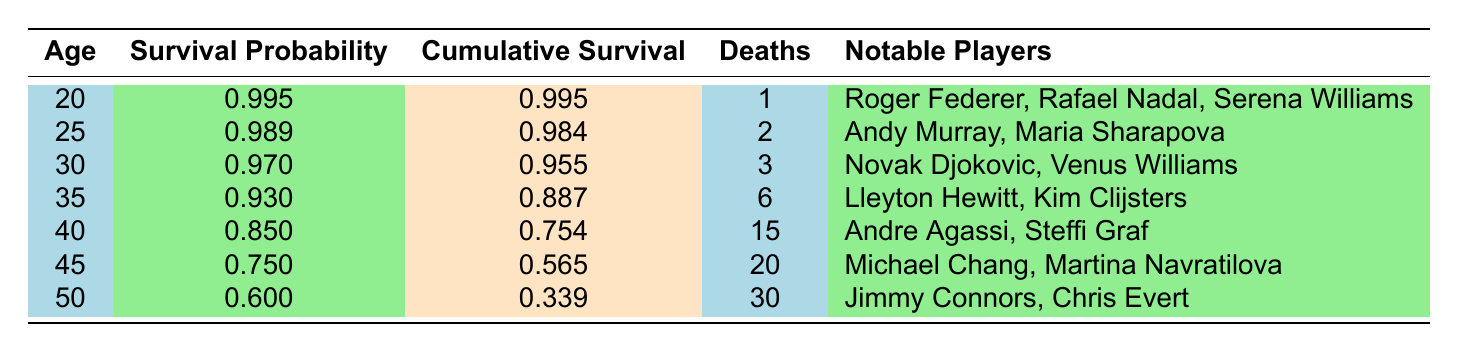What is the survival probability for players aged 40? The survival probability at age 40 is listed in the table, where it shows a value of 0.850.
Answer: 0.850 How many notable players died at age 50? The table indicates that there are 30 deaths listed for players aged 50.
Answer: 30 Which age group has the highest cumulative survival rate? To determine this, we look at the cumulative survival column. The highest cumulative survival rate is 0.995 for the age group of 20 years.
Answer: 20 What is the difference in survival probability between age 25 and age 35? The survival probability for age 25 is 0.989, and for age 35 it is 0.930. The difference is 0.989 - 0.930 = 0.059.
Answer: 0.059 Is it true that the cumulative survival at age 30 is higher than at age 45? The cumulative survival at age 30 is 0.955, and at age 45 it is 0.565, which confirms that 0.955 is higher than 0.565.
Answer: Yes What is the total number of deaths recorded for players aged 40 and older? We sum the deaths for ages 40, 45, and 50: 15 + 20 + 30 = 65.
Answer: 65 At what age does the survival probability first drop below 0.900? By reviewing the survival probabilities, it drops below 0.900 at age 35, where the survival probability is 0.930 and the next age (40) shows 0.850.
Answer: 35 Which players are associated with the highest number of deaths at age 50? The table notes that for age 50, there are 30 deaths, and the notable players at this age are Jimmy Connors and Chris Evert.
Answer: Jimmy Connors, Chris Evert How many players are listed in total for ages 20 to 30? The total is calculated by counting the players listed at each relevant age: 3 at age 20, 2 at age 25, and 2 at age 30, resulting in 3 + 2 + 2 = 7 players in total.
Answer: 7 